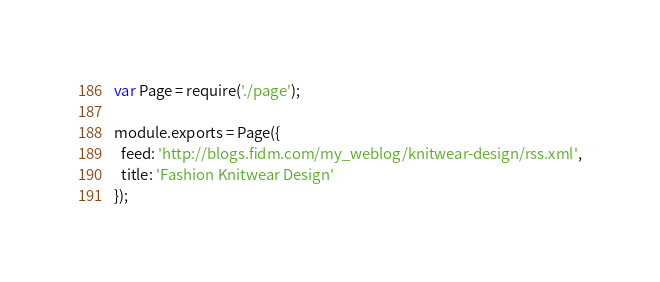<code> <loc_0><loc_0><loc_500><loc_500><_JavaScript_>var Page = require('./page');

module.exports = Page({
  feed: 'http://blogs.fidm.com/my_weblog/knitwear-design/rss.xml',
  title: 'Fashion Knitwear Design'
});
</code> 